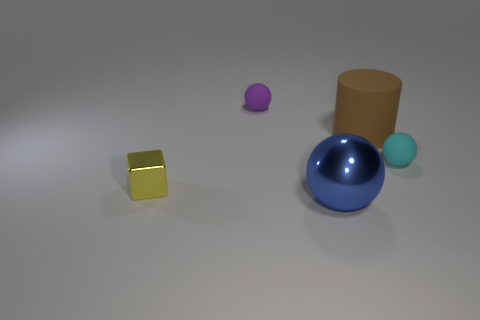Add 1 big yellow rubber cylinders. How many objects exist? 6 Subtract all cylinders. How many objects are left? 4 Subtract all metal objects. Subtract all blue things. How many objects are left? 2 Add 4 small purple balls. How many small purple balls are left? 5 Add 1 large metallic cubes. How many large metallic cubes exist? 1 Subtract 1 blue spheres. How many objects are left? 4 